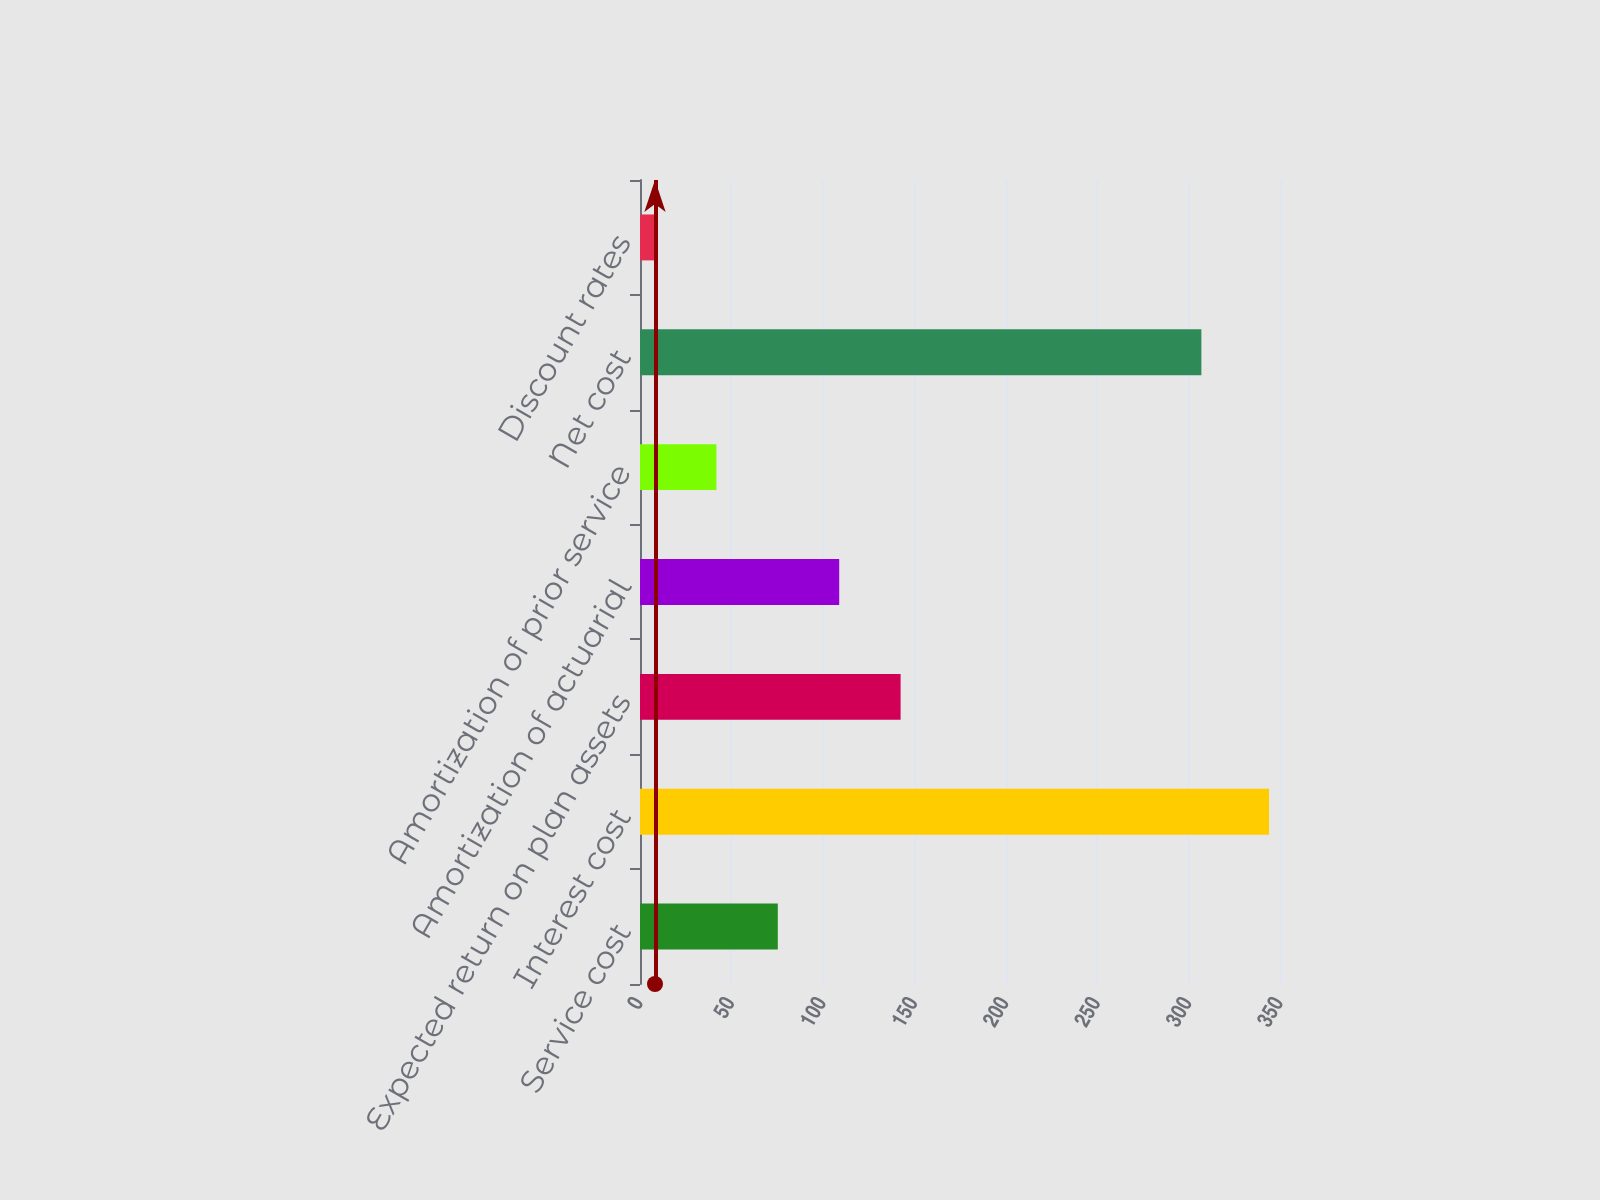<chart> <loc_0><loc_0><loc_500><loc_500><bar_chart><fcel>Service cost<fcel>Interest cost<fcel>Expected return on plan assets<fcel>Amortization of actuarial<fcel>Amortization of prior service<fcel>Net cost<fcel>Discount rates<nl><fcel>75.36<fcel>344<fcel>142.52<fcel>108.94<fcel>41.78<fcel>307<fcel>8.2<nl></chart> 